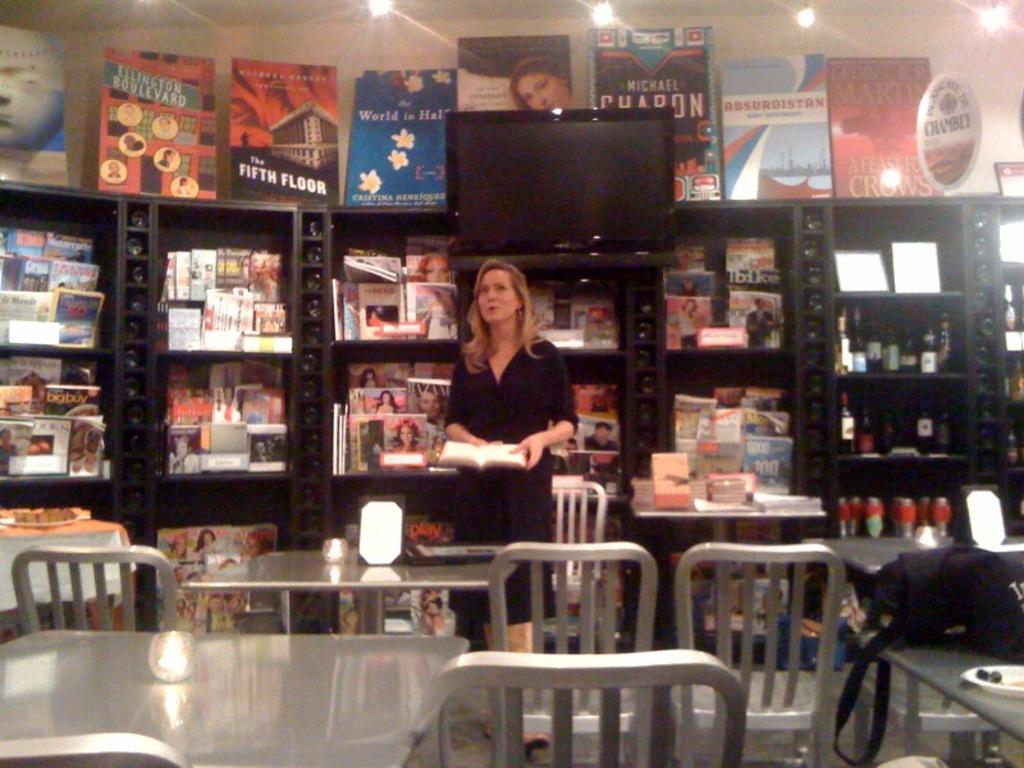Could you give a brief overview of what you see in this image? In this picture I can see a number of chairs and tables. I can see a number of books on the racks. I can see a person standing and holding the book. I can see the screen. I can see light arrangements on the roof. 